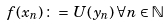<formula> <loc_0><loc_0><loc_500><loc_500>f ( x _ { n } ) \, \colon = \, U ( y _ { n } ) \, \forall n \in { \mathbb { N } }</formula> 